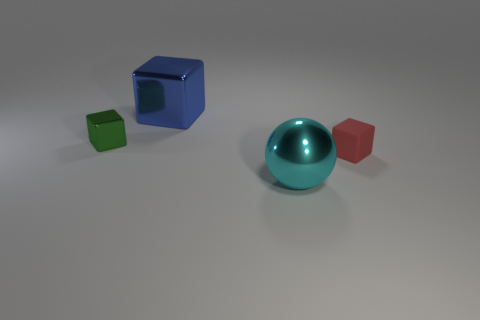Subtract all blocks. How many objects are left? 1 Subtract 3 cubes. How many cubes are left? 0 Subtract all gray blocks. Subtract all brown cylinders. How many blocks are left? 3 Subtract all green cylinders. How many red cubes are left? 1 Subtract all big spheres. Subtract all blue metal cubes. How many objects are left? 2 Add 1 cyan metallic things. How many cyan metallic things are left? 2 Add 3 big red rubber cylinders. How many big red rubber cylinders exist? 3 Add 4 small brown matte cubes. How many objects exist? 8 Subtract all tiny blocks. How many blocks are left? 1 Subtract 0 green spheres. How many objects are left? 4 